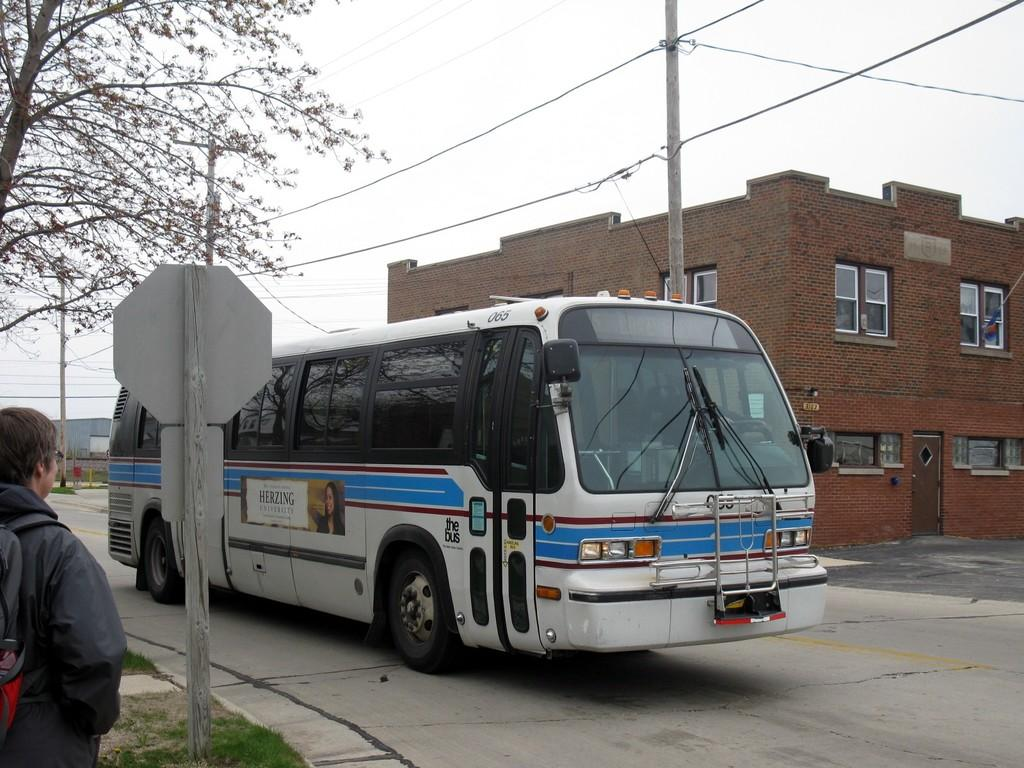What is the main subject in the image? There is a person standing in the image. What can be seen on the road in the image? There is a bus on the road in the image. What is visible in the background of the image? There is a building, wires attached to poles, a tree, and the sky visible in the background of the image. How many pigs are visible in the image? There are no pigs present in the image. What type of coil is being used to power the bus in the image? The image does not show any coils or power sources for the bus; it only shows the bus on the road. 